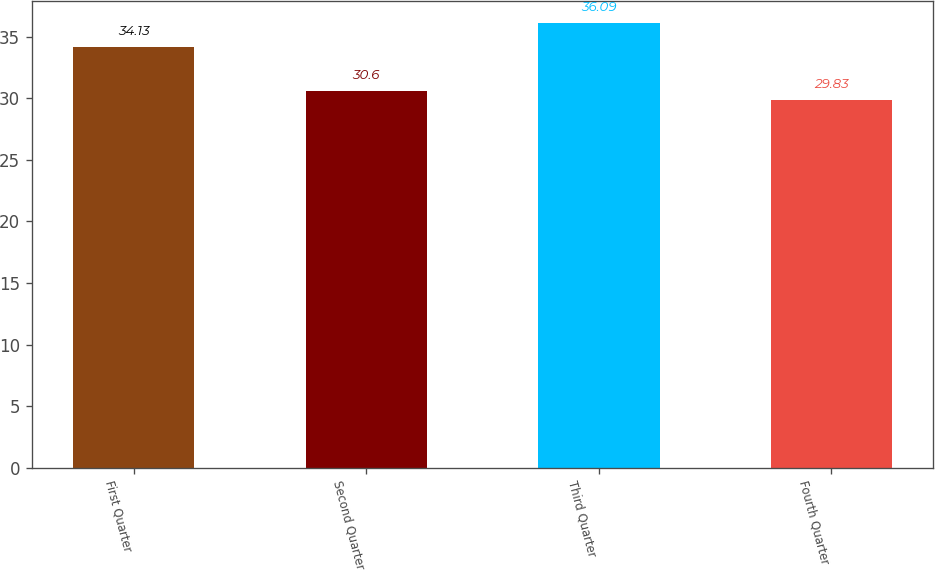Convert chart to OTSL. <chart><loc_0><loc_0><loc_500><loc_500><bar_chart><fcel>First Quarter<fcel>Second Quarter<fcel>Third Quarter<fcel>Fourth Quarter<nl><fcel>34.13<fcel>30.6<fcel>36.09<fcel>29.83<nl></chart> 